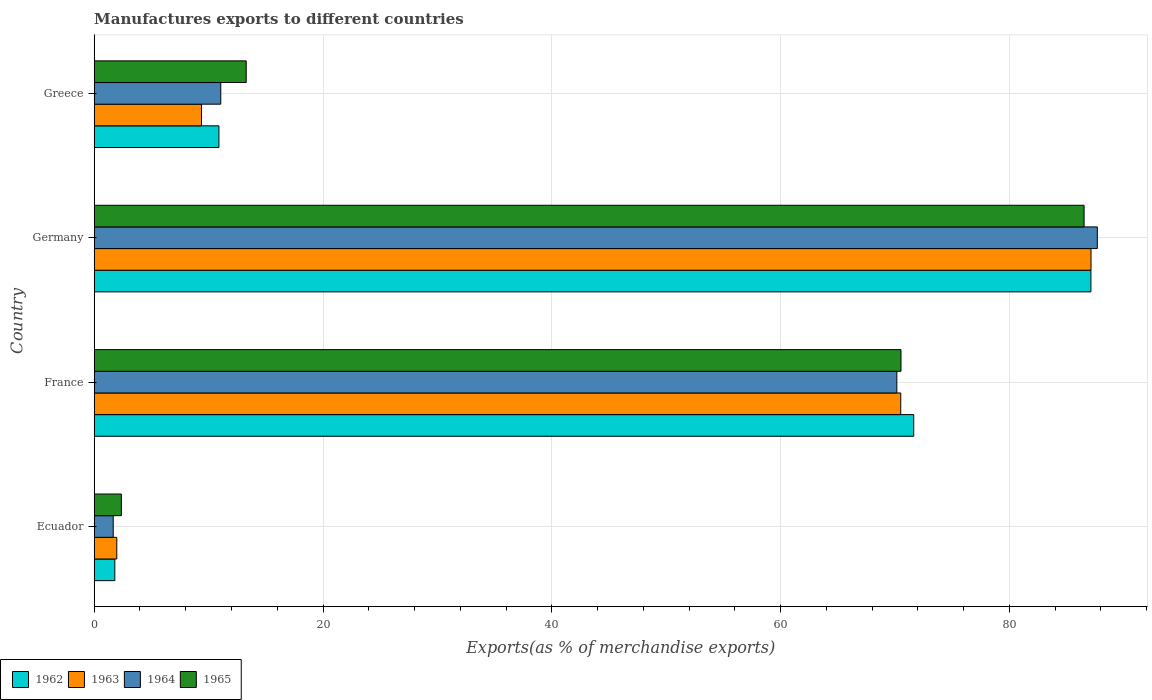How many groups of bars are there?
Give a very brief answer. 4. How many bars are there on the 4th tick from the top?
Your answer should be very brief. 4. How many bars are there on the 4th tick from the bottom?
Ensure brevity in your answer.  4. What is the label of the 4th group of bars from the top?
Offer a very short reply. Ecuador. What is the percentage of exports to different countries in 1964 in Ecuador?
Provide a succinct answer. 1.66. Across all countries, what is the maximum percentage of exports to different countries in 1965?
Keep it short and to the point. 86.53. Across all countries, what is the minimum percentage of exports to different countries in 1963?
Provide a succinct answer. 1.97. In which country was the percentage of exports to different countries in 1964 minimum?
Your response must be concise. Ecuador. What is the total percentage of exports to different countries in 1963 in the graph?
Provide a succinct answer. 168.99. What is the difference between the percentage of exports to different countries in 1964 in Ecuador and that in Greece?
Ensure brevity in your answer.  -9.4. What is the difference between the percentage of exports to different countries in 1965 in France and the percentage of exports to different countries in 1962 in Germany?
Ensure brevity in your answer.  -16.6. What is the average percentage of exports to different countries in 1963 per country?
Offer a terse response. 42.25. What is the difference between the percentage of exports to different countries in 1965 and percentage of exports to different countries in 1962 in Germany?
Offer a terse response. -0.6. In how many countries, is the percentage of exports to different countries in 1964 greater than 52 %?
Offer a very short reply. 2. What is the ratio of the percentage of exports to different countries in 1963 in Germany to that in Greece?
Provide a succinct answer. 9.29. Is the difference between the percentage of exports to different countries in 1965 in Germany and Greece greater than the difference between the percentage of exports to different countries in 1962 in Germany and Greece?
Provide a succinct answer. No. What is the difference between the highest and the second highest percentage of exports to different countries in 1965?
Offer a very short reply. 16.01. What is the difference between the highest and the lowest percentage of exports to different countries in 1962?
Make the answer very short. 85.32. Is the sum of the percentage of exports to different countries in 1962 in France and Germany greater than the maximum percentage of exports to different countries in 1965 across all countries?
Offer a terse response. Yes. Is it the case that in every country, the sum of the percentage of exports to different countries in 1962 and percentage of exports to different countries in 1965 is greater than the percentage of exports to different countries in 1963?
Ensure brevity in your answer.  Yes. Are all the bars in the graph horizontal?
Make the answer very short. Yes. What is the difference between two consecutive major ticks on the X-axis?
Keep it short and to the point. 20. Are the values on the major ticks of X-axis written in scientific E-notation?
Provide a succinct answer. No. Does the graph contain any zero values?
Keep it short and to the point. No. Does the graph contain grids?
Make the answer very short. Yes. Where does the legend appear in the graph?
Your answer should be compact. Bottom left. How many legend labels are there?
Ensure brevity in your answer.  4. How are the legend labels stacked?
Ensure brevity in your answer.  Horizontal. What is the title of the graph?
Provide a short and direct response. Manufactures exports to different countries. Does "2012" appear as one of the legend labels in the graph?
Give a very brief answer. No. What is the label or title of the X-axis?
Give a very brief answer. Exports(as % of merchandise exports). What is the label or title of the Y-axis?
Your answer should be compact. Country. What is the Exports(as % of merchandise exports) in 1962 in Ecuador?
Ensure brevity in your answer.  1.8. What is the Exports(as % of merchandise exports) of 1963 in Ecuador?
Your answer should be compact. 1.97. What is the Exports(as % of merchandise exports) in 1964 in Ecuador?
Your answer should be very brief. 1.66. What is the Exports(as % of merchandise exports) of 1965 in Ecuador?
Ensure brevity in your answer.  2.37. What is the Exports(as % of merchandise exports) in 1962 in France?
Keep it short and to the point. 71.64. What is the Exports(as % of merchandise exports) in 1963 in France?
Offer a very short reply. 70.5. What is the Exports(as % of merchandise exports) of 1964 in France?
Your answer should be compact. 70.16. What is the Exports(as % of merchandise exports) of 1965 in France?
Your answer should be compact. 70.52. What is the Exports(as % of merchandise exports) of 1962 in Germany?
Provide a short and direct response. 87.12. What is the Exports(as % of merchandise exports) in 1963 in Germany?
Keep it short and to the point. 87.13. What is the Exports(as % of merchandise exports) of 1964 in Germany?
Make the answer very short. 87.69. What is the Exports(as % of merchandise exports) in 1965 in Germany?
Your answer should be compact. 86.53. What is the Exports(as % of merchandise exports) of 1962 in Greece?
Provide a succinct answer. 10.9. What is the Exports(as % of merchandise exports) of 1963 in Greece?
Keep it short and to the point. 9.38. What is the Exports(as % of merchandise exports) in 1964 in Greece?
Your answer should be very brief. 11.06. What is the Exports(as % of merchandise exports) in 1965 in Greece?
Offer a very short reply. 13.29. Across all countries, what is the maximum Exports(as % of merchandise exports) in 1962?
Provide a succinct answer. 87.12. Across all countries, what is the maximum Exports(as % of merchandise exports) in 1963?
Ensure brevity in your answer.  87.13. Across all countries, what is the maximum Exports(as % of merchandise exports) of 1964?
Provide a succinct answer. 87.69. Across all countries, what is the maximum Exports(as % of merchandise exports) in 1965?
Your answer should be very brief. 86.53. Across all countries, what is the minimum Exports(as % of merchandise exports) in 1962?
Your answer should be very brief. 1.8. Across all countries, what is the minimum Exports(as % of merchandise exports) of 1963?
Keep it short and to the point. 1.97. Across all countries, what is the minimum Exports(as % of merchandise exports) of 1964?
Keep it short and to the point. 1.66. Across all countries, what is the minimum Exports(as % of merchandise exports) in 1965?
Provide a short and direct response. 2.37. What is the total Exports(as % of merchandise exports) in 1962 in the graph?
Ensure brevity in your answer.  171.47. What is the total Exports(as % of merchandise exports) of 1963 in the graph?
Your answer should be very brief. 168.99. What is the total Exports(as % of merchandise exports) in 1964 in the graph?
Provide a succinct answer. 170.57. What is the total Exports(as % of merchandise exports) in 1965 in the graph?
Your answer should be compact. 172.71. What is the difference between the Exports(as % of merchandise exports) in 1962 in Ecuador and that in France?
Offer a terse response. -69.83. What is the difference between the Exports(as % of merchandise exports) of 1963 in Ecuador and that in France?
Give a very brief answer. -68.53. What is the difference between the Exports(as % of merchandise exports) in 1964 in Ecuador and that in France?
Offer a very short reply. -68.5. What is the difference between the Exports(as % of merchandise exports) in 1965 in Ecuador and that in France?
Ensure brevity in your answer.  -68.15. What is the difference between the Exports(as % of merchandise exports) of 1962 in Ecuador and that in Germany?
Provide a short and direct response. -85.32. What is the difference between the Exports(as % of merchandise exports) in 1963 in Ecuador and that in Germany?
Keep it short and to the point. -85.16. What is the difference between the Exports(as % of merchandise exports) of 1964 in Ecuador and that in Germany?
Give a very brief answer. -86.02. What is the difference between the Exports(as % of merchandise exports) of 1965 in Ecuador and that in Germany?
Make the answer very short. -84.15. What is the difference between the Exports(as % of merchandise exports) in 1962 in Ecuador and that in Greece?
Provide a short and direct response. -9.1. What is the difference between the Exports(as % of merchandise exports) of 1963 in Ecuador and that in Greece?
Your answer should be compact. -7.41. What is the difference between the Exports(as % of merchandise exports) in 1964 in Ecuador and that in Greece?
Give a very brief answer. -9.4. What is the difference between the Exports(as % of merchandise exports) of 1965 in Ecuador and that in Greece?
Make the answer very short. -10.91. What is the difference between the Exports(as % of merchandise exports) of 1962 in France and that in Germany?
Make the answer very short. -15.49. What is the difference between the Exports(as % of merchandise exports) in 1963 in France and that in Germany?
Your answer should be compact. -16.63. What is the difference between the Exports(as % of merchandise exports) in 1964 in France and that in Germany?
Offer a terse response. -17.53. What is the difference between the Exports(as % of merchandise exports) in 1965 in France and that in Germany?
Keep it short and to the point. -16.01. What is the difference between the Exports(as % of merchandise exports) of 1962 in France and that in Greece?
Make the answer very short. 60.73. What is the difference between the Exports(as % of merchandise exports) of 1963 in France and that in Greece?
Keep it short and to the point. 61.12. What is the difference between the Exports(as % of merchandise exports) of 1964 in France and that in Greece?
Ensure brevity in your answer.  59.1. What is the difference between the Exports(as % of merchandise exports) of 1965 in France and that in Greece?
Make the answer very short. 57.23. What is the difference between the Exports(as % of merchandise exports) in 1962 in Germany and that in Greece?
Make the answer very short. 76.22. What is the difference between the Exports(as % of merchandise exports) in 1963 in Germany and that in Greece?
Keep it short and to the point. 77.75. What is the difference between the Exports(as % of merchandise exports) in 1964 in Germany and that in Greece?
Your answer should be compact. 76.62. What is the difference between the Exports(as % of merchandise exports) of 1965 in Germany and that in Greece?
Give a very brief answer. 73.24. What is the difference between the Exports(as % of merchandise exports) in 1962 in Ecuador and the Exports(as % of merchandise exports) in 1963 in France?
Your response must be concise. -68.7. What is the difference between the Exports(as % of merchandise exports) in 1962 in Ecuador and the Exports(as % of merchandise exports) in 1964 in France?
Give a very brief answer. -68.35. What is the difference between the Exports(as % of merchandise exports) in 1962 in Ecuador and the Exports(as % of merchandise exports) in 1965 in France?
Provide a succinct answer. -68.72. What is the difference between the Exports(as % of merchandise exports) of 1963 in Ecuador and the Exports(as % of merchandise exports) of 1964 in France?
Offer a very short reply. -68.18. What is the difference between the Exports(as % of merchandise exports) in 1963 in Ecuador and the Exports(as % of merchandise exports) in 1965 in France?
Your response must be concise. -68.55. What is the difference between the Exports(as % of merchandise exports) of 1964 in Ecuador and the Exports(as % of merchandise exports) of 1965 in France?
Provide a short and direct response. -68.86. What is the difference between the Exports(as % of merchandise exports) in 1962 in Ecuador and the Exports(as % of merchandise exports) in 1963 in Germany?
Your response must be concise. -85.33. What is the difference between the Exports(as % of merchandise exports) in 1962 in Ecuador and the Exports(as % of merchandise exports) in 1964 in Germany?
Your answer should be very brief. -85.88. What is the difference between the Exports(as % of merchandise exports) in 1962 in Ecuador and the Exports(as % of merchandise exports) in 1965 in Germany?
Keep it short and to the point. -84.72. What is the difference between the Exports(as % of merchandise exports) of 1963 in Ecuador and the Exports(as % of merchandise exports) of 1964 in Germany?
Your response must be concise. -85.71. What is the difference between the Exports(as % of merchandise exports) of 1963 in Ecuador and the Exports(as % of merchandise exports) of 1965 in Germany?
Offer a terse response. -84.55. What is the difference between the Exports(as % of merchandise exports) of 1964 in Ecuador and the Exports(as % of merchandise exports) of 1965 in Germany?
Offer a terse response. -84.87. What is the difference between the Exports(as % of merchandise exports) of 1962 in Ecuador and the Exports(as % of merchandise exports) of 1963 in Greece?
Offer a terse response. -7.58. What is the difference between the Exports(as % of merchandise exports) of 1962 in Ecuador and the Exports(as % of merchandise exports) of 1964 in Greece?
Your answer should be very brief. -9.26. What is the difference between the Exports(as % of merchandise exports) of 1962 in Ecuador and the Exports(as % of merchandise exports) of 1965 in Greece?
Provide a succinct answer. -11.48. What is the difference between the Exports(as % of merchandise exports) in 1963 in Ecuador and the Exports(as % of merchandise exports) in 1964 in Greece?
Your answer should be very brief. -9.09. What is the difference between the Exports(as % of merchandise exports) of 1963 in Ecuador and the Exports(as % of merchandise exports) of 1965 in Greece?
Make the answer very short. -11.31. What is the difference between the Exports(as % of merchandise exports) in 1964 in Ecuador and the Exports(as % of merchandise exports) in 1965 in Greece?
Offer a terse response. -11.63. What is the difference between the Exports(as % of merchandise exports) of 1962 in France and the Exports(as % of merchandise exports) of 1963 in Germany?
Provide a short and direct response. -15.5. What is the difference between the Exports(as % of merchandise exports) in 1962 in France and the Exports(as % of merchandise exports) in 1964 in Germany?
Provide a succinct answer. -16.05. What is the difference between the Exports(as % of merchandise exports) of 1962 in France and the Exports(as % of merchandise exports) of 1965 in Germany?
Keep it short and to the point. -14.89. What is the difference between the Exports(as % of merchandise exports) in 1963 in France and the Exports(as % of merchandise exports) in 1964 in Germany?
Provide a short and direct response. -17.18. What is the difference between the Exports(as % of merchandise exports) of 1963 in France and the Exports(as % of merchandise exports) of 1965 in Germany?
Offer a terse response. -16.03. What is the difference between the Exports(as % of merchandise exports) in 1964 in France and the Exports(as % of merchandise exports) in 1965 in Germany?
Your response must be concise. -16.37. What is the difference between the Exports(as % of merchandise exports) of 1962 in France and the Exports(as % of merchandise exports) of 1963 in Greece?
Offer a terse response. 62.25. What is the difference between the Exports(as % of merchandise exports) of 1962 in France and the Exports(as % of merchandise exports) of 1964 in Greece?
Offer a terse response. 60.57. What is the difference between the Exports(as % of merchandise exports) of 1962 in France and the Exports(as % of merchandise exports) of 1965 in Greece?
Make the answer very short. 58.35. What is the difference between the Exports(as % of merchandise exports) in 1963 in France and the Exports(as % of merchandise exports) in 1964 in Greece?
Keep it short and to the point. 59.44. What is the difference between the Exports(as % of merchandise exports) in 1963 in France and the Exports(as % of merchandise exports) in 1965 in Greece?
Provide a short and direct response. 57.21. What is the difference between the Exports(as % of merchandise exports) in 1964 in France and the Exports(as % of merchandise exports) in 1965 in Greece?
Your answer should be compact. 56.87. What is the difference between the Exports(as % of merchandise exports) in 1962 in Germany and the Exports(as % of merchandise exports) in 1963 in Greece?
Offer a terse response. 77.74. What is the difference between the Exports(as % of merchandise exports) in 1962 in Germany and the Exports(as % of merchandise exports) in 1964 in Greece?
Give a very brief answer. 76.06. What is the difference between the Exports(as % of merchandise exports) in 1962 in Germany and the Exports(as % of merchandise exports) in 1965 in Greece?
Provide a short and direct response. 73.84. What is the difference between the Exports(as % of merchandise exports) of 1963 in Germany and the Exports(as % of merchandise exports) of 1964 in Greece?
Offer a terse response. 76.07. What is the difference between the Exports(as % of merchandise exports) of 1963 in Germany and the Exports(as % of merchandise exports) of 1965 in Greece?
Provide a short and direct response. 73.84. What is the difference between the Exports(as % of merchandise exports) of 1964 in Germany and the Exports(as % of merchandise exports) of 1965 in Greece?
Give a very brief answer. 74.4. What is the average Exports(as % of merchandise exports) in 1962 per country?
Provide a short and direct response. 42.87. What is the average Exports(as % of merchandise exports) of 1963 per country?
Your response must be concise. 42.25. What is the average Exports(as % of merchandise exports) in 1964 per country?
Your answer should be very brief. 42.64. What is the average Exports(as % of merchandise exports) in 1965 per country?
Make the answer very short. 43.18. What is the difference between the Exports(as % of merchandise exports) in 1962 and Exports(as % of merchandise exports) in 1963 in Ecuador?
Keep it short and to the point. -0.17. What is the difference between the Exports(as % of merchandise exports) in 1962 and Exports(as % of merchandise exports) in 1964 in Ecuador?
Give a very brief answer. 0.14. What is the difference between the Exports(as % of merchandise exports) of 1962 and Exports(as % of merchandise exports) of 1965 in Ecuador?
Your response must be concise. -0.57. What is the difference between the Exports(as % of merchandise exports) in 1963 and Exports(as % of merchandise exports) in 1964 in Ecuador?
Ensure brevity in your answer.  0.31. What is the difference between the Exports(as % of merchandise exports) in 1963 and Exports(as % of merchandise exports) in 1965 in Ecuador?
Give a very brief answer. -0.4. What is the difference between the Exports(as % of merchandise exports) in 1964 and Exports(as % of merchandise exports) in 1965 in Ecuador?
Your answer should be very brief. -0.71. What is the difference between the Exports(as % of merchandise exports) in 1962 and Exports(as % of merchandise exports) in 1963 in France?
Your response must be concise. 1.13. What is the difference between the Exports(as % of merchandise exports) in 1962 and Exports(as % of merchandise exports) in 1964 in France?
Ensure brevity in your answer.  1.48. What is the difference between the Exports(as % of merchandise exports) of 1962 and Exports(as % of merchandise exports) of 1965 in France?
Your answer should be compact. 1.11. What is the difference between the Exports(as % of merchandise exports) of 1963 and Exports(as % of merchandise exports) of 1964 in France?
Offer a very short reply. 0.34. What is the difference between the Exports(as % of merchandise exports) in 1963 and Exports(as % of merchandise exports) in 1965 in France?
Ensure brevity in your answer.  -0.02. What is the difference between the Exports(as % of merchandise exports) in 1964 and Exports(as % of merchandise exports) in 1965 in France?
Provide a succinct answer. -0.36. What is the difference between the Exports(as % of merchandise exports) in 1962 and Exports(as % of merchandise exports) in 1963 in Germany?
Offer a very short reply. -0.01. What is the difference between the Exports(as % of merchandise exports) of 1962 and Exports(as % of merchandise exports) of 1964 in Germany?
Make the answer very short. -0.56. What is the difference between the Exports(as % of merchandise exports) of 1962 and Exports(as % of merchandise exports) of 1965 in Germany?
Give a very brief answer. 0.6. What is the difference between the Exports(as % of merchandise exports) in 1963 and Exports(as % of merchandise exports) in 1964 in Germany?
Give a very brief answer. -0.55. What is the difference between the Exports(as % of merchandise exports) in 1963 and Exports(as % of merchandise exports) in 1965 in Germany?
Offer a terse response. 0.6. What is the difference between the Exports(as % of merchandise exports) in 1964 and Exports(as % of merchandise exports) in 1965 in Germany?
Offer a terse response. 1.16. What is the difference between the Exports(as % of merchandise exports) of 1962 and Exports(as % of merchandise exports) of 1963 in Greece?
Offer a very short reply. 1.52. What is the difference between the Exports(as % of merchandise exports) of 1962 and Exports(as % of merchandise exports) of 1964 in Greece?
Keep it short and to the point. -0.16. What is the difference between the Exports(as % of merchandise exports) of 1962 and Exports(as % of merchandise exports) of 1965 in Greece?
Make the answer very short. -2.39. What is the difference between the Exports(as % of merchandise exports) of 1963 and Exports(as % of merchandise exports) of 1964 in Greece?
Provide a succinct answer. -1.68. What is the difference between the Exports(as % of merchandise exports) of 1963 and Exports(as % of merchandise exports) of 1965 in Greece?
Your answer should be very brief. -3.91. What is the difference between the Exports(as % of merchandise exports) of 1964 and Exports(as % of merchandise exports) of 1965 in Greece?
Provide a succinct answer. -2.23. What is the ratio of the Exports(as % of merchandise exports) in 1962 in Ecuador to that in France?
Your response must be concise. 0.03. What is the ratio of the Exports(as % of merchandise exports) in 1963 in Ecuador to that in France?
Make the answer very short. 0.03. What is the ratio of the Exports(as % of merchandise exports) in 1964 in Ecuador to that in France?
Your answer should be compact. 0.02. What is the ratio of the Exports(as % of merchandise exports) of 1965 in Ecuador to that in France?
Provide a short and direct response. 0.03. What is the ratio of the Exports(as % of merchandise exports) of 1962 in Ecuador to that in Germany?
Your answer should be compact. 0.02. What is the ratio of the Exports(as % of merchandise exports) of 1963 in Ecuador to that in Germany?
Your response must be concise. 0.02. What is the ratio of the Exports(as % of merchandise exports) of 1964 in Ecuador to that in Germany?
Keep it short and to the point. 0.02. What is the ratio of the Exports(as % of merchandise exports) in 1965 in Ecuador to that in Germany?
Your response must be concise. 0.03. What is the ratio of the Exports(as % of merchandise exports) in 1962 in Ecuador to that in Greece?
Give a very brief answer. 0.17. What is the ratio of the Exports(as % of merchandise exports) of 1963 in Ecuador to that in Greece?
Make the answer very short. 0.21. What is the ratio of the Exports(as % of merchandise exports) in 1964 in Ecuador to that in Greece?
Offer a terse response. 0.15. What is the ratio of the Exports(as % of merchandise exports) in 1965 in Ecuador to that in Greece?
Your response must be concise. 0.18. What is the ratio of the Exports(as % of merchandise exports) in 1962 in France to that in Germany?
Ensure brevity in your answer.  0.82. What is the ratio of the Exports(as % of merchandise exports) in 1963 in France to that in Germany?
Keep it short and to the point. 0.81. What is the ratio of the Exports(as % of merchandise exports) of 1964 in France to that in Germany?
Your answer should be compact. 0.8. What is the ratio of the Exports(as % of merchandise exports) of 1965 in France to that in Germany?
Offer a very short reply. 0.81. What is the ratio of the Exports(as % of merchandise exports) of 1962 in France to that in Greece?
Offer a terse response. 6.57. What is the ratio of the Exports(as % of merchandise exports) of 1963 in France to that in Greece?
Provide a succinct answer. 7.51. What is the ratio of the Exports(as % of merchandise exports) in 1964 in France to that in Greece?
Your response must be concise. 6.34. What is the ratio of the Exports(as % of merchandise exports) of 1965 in France to that in Greece?
Give a very brief answer. 5.31. What is the ratio of the Exports(as % of merchandise exports) in 1962 in Germany to that in Greece?
Provide a succinct answer. 7.99. What is the ratio of the Exports(as % of merchandise exports) in 1963 in Germany to that in Greece?
Give a very brief answer. 9.29. What is the ratio of the Exports(as % of merchandise exports) of 1964 in Germany to that in Greece?
Ensure brevity in your answer.  7.93. What is the ratio of the Exports(as % of merchandise exports) of 1965 in Germany to that in Greece?
Ensure brevity in your answer.  6.51. What is the difference between the highest and the second highest Exports(as % of merchandise exports) of 1962?
Your response must be concise. 15.49. What is the difference between the highest and the second highest Exports(as % of merchandise exports) of 1963?
Give a very brief answer. 16.63. What is the difference between the highest and the second highest Exports(as % of merchandise exports) of 1964?
Provide a succinct answer. 17.53. What is the difference between the highest and the second highest Exports(as % of merchandise exports) in 1965?
Make the answer very short. 16.01. What is the difference between the highest and the lowest Exports(as % of merchandise exports) in 1962?
Provide a succinct answer. 85.32. What is the difference between the highest and the lowest Exports(as % of merchandise exports) in 1963?
Ensure brevity in your answer.  85.16. What is the difference between the highest and the lowest Exports(as % of merchandise exports) in 1964?
Keep it short and to the point. 86.02. What is the difference between the highest and the lowest Exports(as % of merchandise exports) in 1965?
Offer a very short reply. 84.15. 